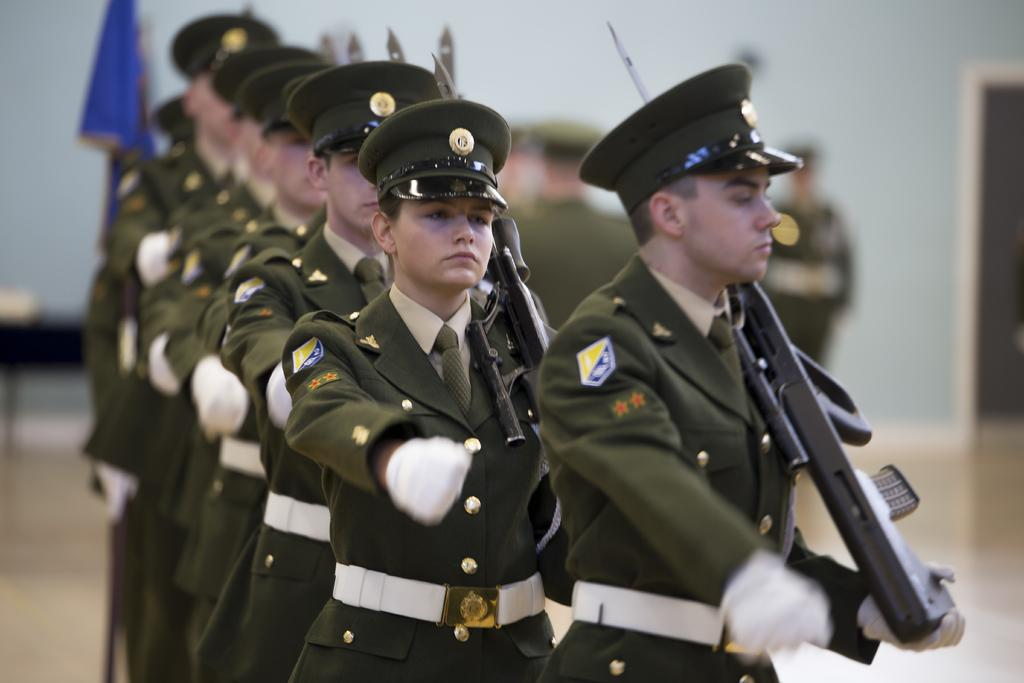What are the people in the foreground of the image doing? The people in the foreground of the image are walking in a line. What are the people holding while walking in the foreground? The people are holding guns on the floor. What can be seen in the background of the image? There is a blue color flag and a wall in the background of the image. Are there any other people visible in the image? Yes, there are people standing in the background of the image. What type of sugar is being used to clean the guns in the image? There is no sugar present in the image, and the guns are not being cleaned. Is there a carpenter working on the wall in the background of the image? There is no carpenter visible in the image, and no work on the wall is being depicted. 